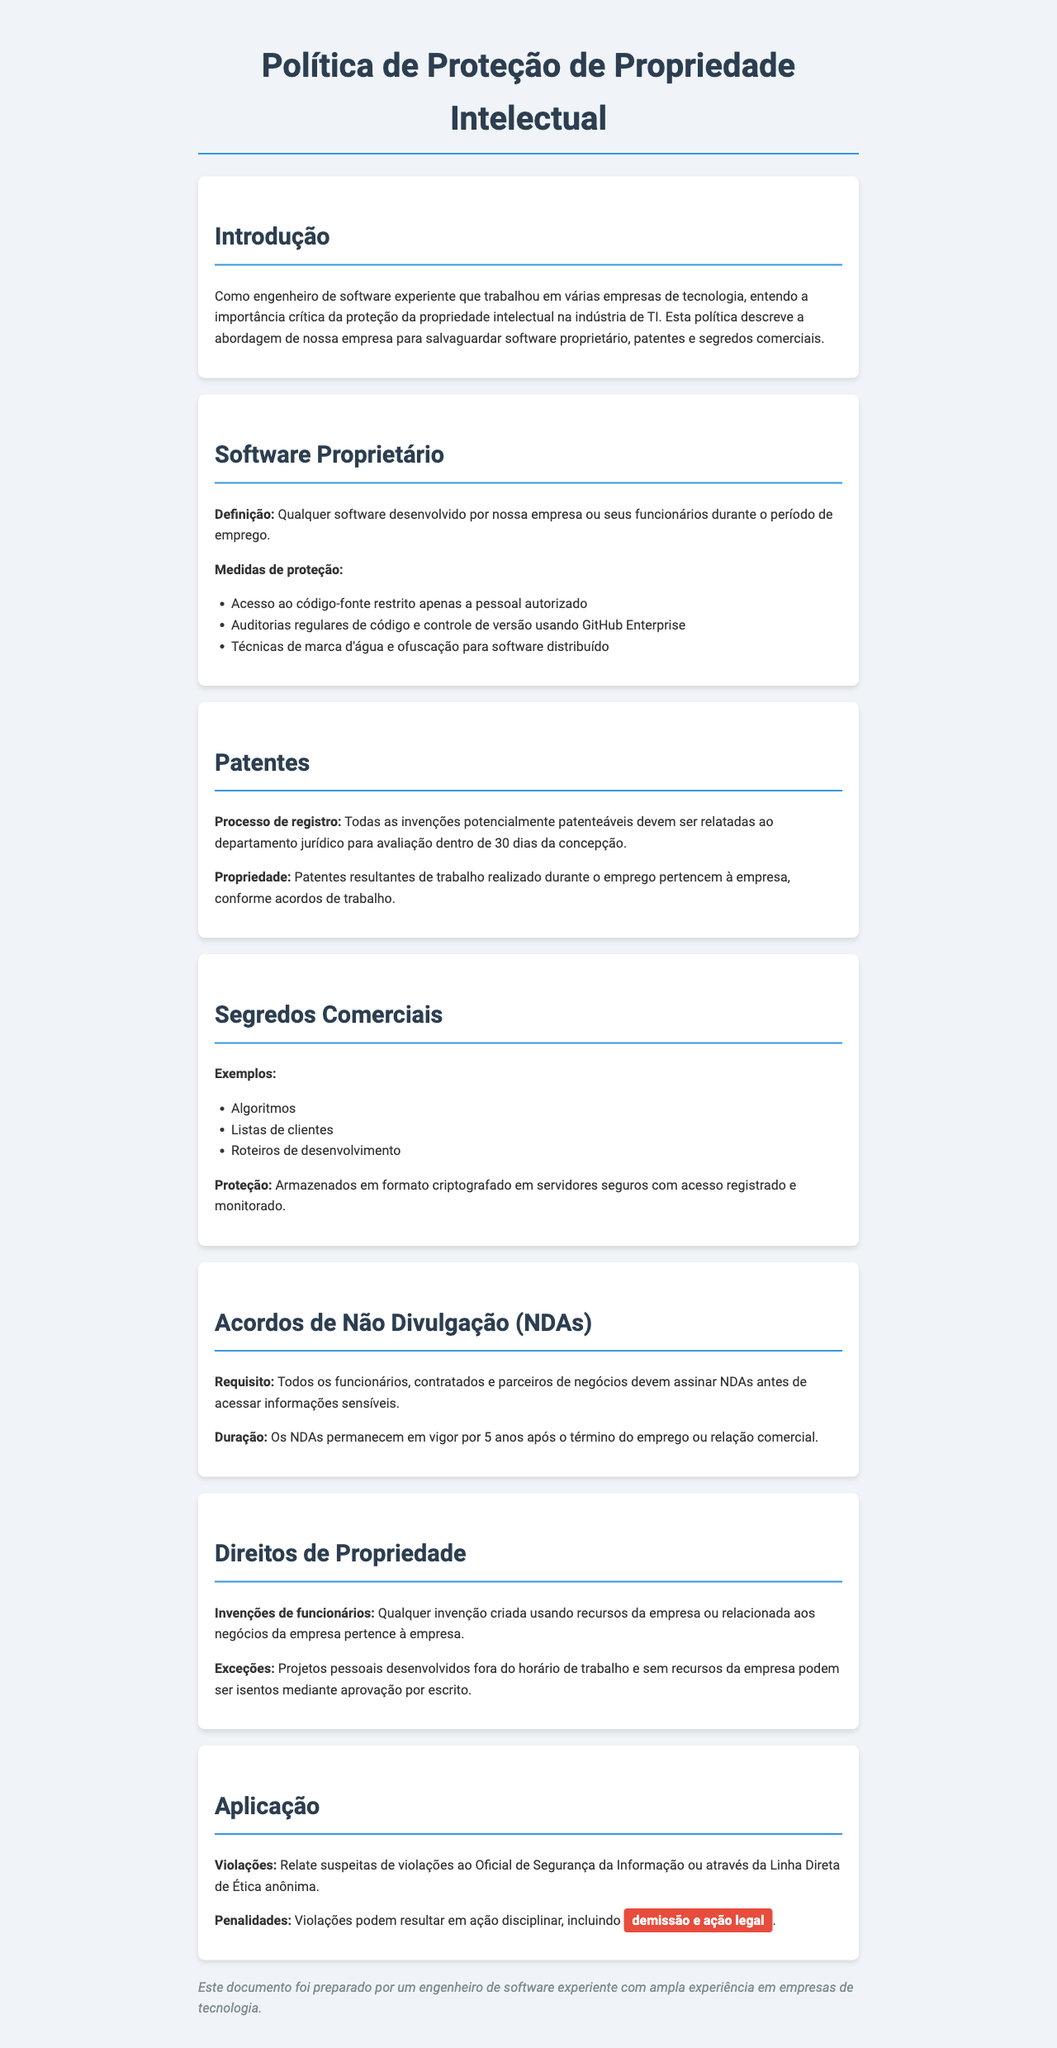qual é a definição de software proprietário? A definição está na seção sobre Software Proprietário e diz que é qualquer software desenvolvido por nossa empresa ou seus funcionários durante o período de emprego.
Answer: Qualquer software desenvolvido por nossa empresa ou seus funcionários durante o período de emprego qual é o prazo para relatar invenções potencialmente patenteáveis? O prazo para relatar invenções está na seção de Patentes e é de 30 dias da concepção.
Answer: 30 dias que exemplo é dado como um segredo comercial? Um exemplo de segredo comercial é mencionado na seção de Segredos Comerciais.
Answer: Algoritmos qual é a duração dos Acordos de Não Divulgação? A duração dos NDAs é mencionada na seção correspondente e é de 5 anos.
Answer: 5 anos quem deve assinar os NDAs? A seção de Acordos de Não Divulgação especifica que todos os funcionários, contratados e parceiros de negócios devem assinar NDAs.
Answer: Todos os funcionários, contratados e parceiros de negócios qual é a consequência de violações da política? A seção de Aplicação menciona que as violações podem resultar em ação disciplinar, incluindo demissão e ação legal.
Answer: Demissão e ação legal que tipo de invenções pertencem à empresa? A seção de Direitos de Propriedade explica que invenções criadas usando recursos da empresa ou relacionadas aos negócios pertencem à empresa.
Answer: Invenções criadas usando recursos da empresa ou relacionadas aos negócios quais técnicas são usadas para proteger o software distribuído? A seção sobre Software Proprietário menciona técnicas como marca d'água e ofuscação para softwares distribuídos.
Answer: Marca d'água e ofuscação 